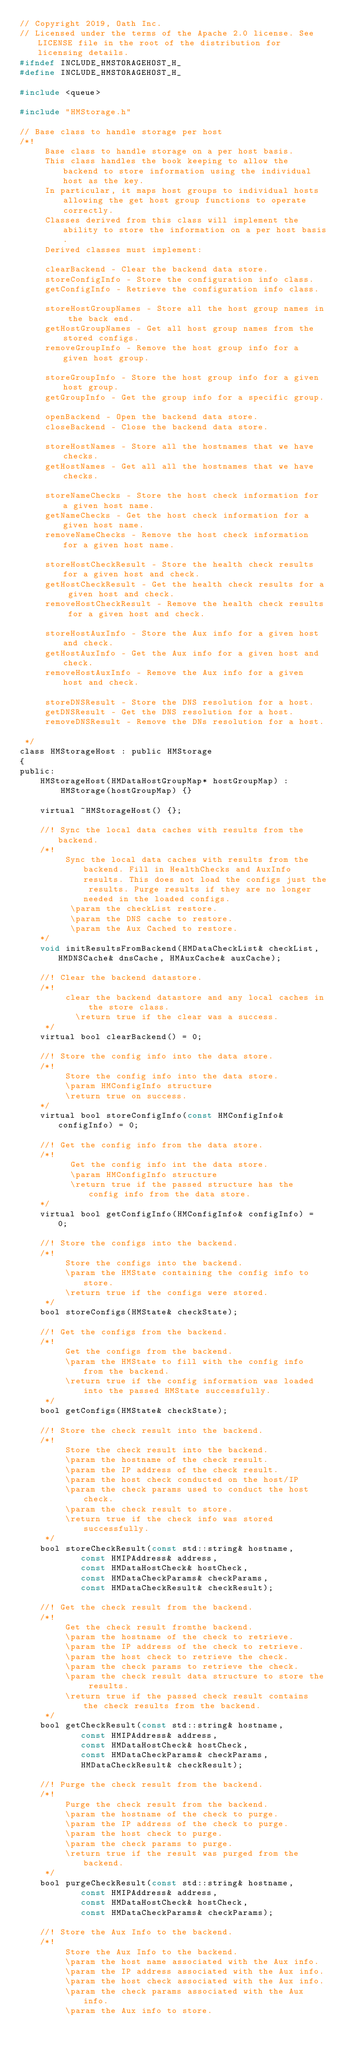<code> <loc_0><loc_0><loc_500><loc_500><_C_>// Copyright 2019, Oath Inc.
// Licensed under the terms of the Apache 2.0 license. See LICENSE file in the root of the distribution for licensing details.
#ifndef INCLUDE_HMSTORAGEHOST_H_
#define INCLUDE_HMSTORAGEHOST_H_

#include <queue>

#include "HMStorage.h"

// Base class to handle storage per host
/*!
     Base class to handle storage on a per host basis.
     This class handles the book keeping to allow the backend to store information using the individual host as the key.
     In particular, it maps host groups to individual hosts allowing the get host group functions to operate correctly.
     Classes derived from this class will implement the ability to store the information on a per host basis.
     Derived classes must implement:

     clearBackend - Clear the backend data store.
     storeConfigInfo - Store the configuration info class.
     getConfigInfo - Retrieve the configuration info class.

     storeHostGroupNames - Store all the host group names in the back end.
     getHostGroupNames - Get all host group names from the stored configs.
     removeGroupInfo - Remove the host group info for a given host group.

     storeGroupInfo - Store the host group info for a given host group.
     getGroupInfo - Get the group info for a specific group.

     openBackend - Open the backend data store.
     closeBackend - Close the backend data store.

     storeHostNames - Store all the hostnames that we have checks.
     getHostNames - Get all all the hostnames that we have checks.

     storeNameChecks - Store the host check information for a given host name.
     getNameChecks - Get the host check information for a given host name.
     removeNameChecks - Remove the host check information for a given host name.

     storeHostCheckResult - Store the health check results for a given host and check.
     getHostCheckResult - Get the health check results for a given host and check.
     removeHostCheckResult - Remove the health check results for a given host and check.

     storeHostAuxInfo - Store the Aux info for a given host and check.
     getHostAuxInfo - Get the Aux info for a given host and check.
     removeHostAuxInfo - Remove the Aux info for a given host and check.

     storeDNSResult - Store the DNS resolution for a host.
     getDNSResult - Get the DNS resolution for a host.
     removeDNSResult - Remove the DNs resolution for a host.

 */
class HMStorageHost : public HMStorage
{
public:
    HMStorageHost(HMDataHostGroupMap* hostGroupMap) :
        HMStorage(hostGroupMap) {}

    virtual ~HMStorageHost() {};

    //! Sync the local data caches with results from the backend.
    /*!
         Sync the local data caches with results from the backend. Fill in HealthChecks and AuxInfo results. This does not load the configs just the results. Purge results if they are no longer needed in the loaded configs.
          \param the checkList restore.
          \param the DNS cache to restore.
          \param the Aux Cached to restore.
    */
    void initResultsFromBackend(HMDataCheckList& checkList, HMDNSCache& dnsCache, HMAuxCache& auxCache);

    //! Clear the backend datastore.
    /*!
         clear the backend datastore and any local caches in the store class.
           \return true if the clear was a success.
     */
    virtual bool clearBackend() = 0;

    //! Store the config info into the data store.
    /*!
         Store the config info into the data store.
         \param HMConfigInfo structure
         \return true on success.
    */
    virtual bool storeConfigInfo(const HMConfigInfo& configInfo) = 0;

    //! Get the config info from the data store.
    /*!
          Get the config info int the data store.
          \param HMConfigInfo structure
          \return true if the passed structure has the config info from the data store.
    */
    virtual bool getConfigInfo(HMConfigInfo& configInfo) = 0;

    //! Store the configs into the backend.
    /*!
         Store the configs into the backend.
         \param the HMState containing the config info to store.
         \return true if the configs were stored.
     */
    bool storeConfigs(HMState& checkState);

    //! Get the configs from the backend.
    /*!
         Get the configs from the backend.
         \param the HMState to fill with the config info from the backend.
         \return true if the config information was loaded into the passed HMState successfully.
     */
    bool getConfigs(HMState& checkState);

    //! Store the check result into the backend.
    /*!
         Store the check result into the backend.
         \param the hostname of the check result.
         \param the IP address of the check result.
         \param the host check conducted on the host/IP
         \param the check params used to conduct the host check.
         \param the check result to store.
         \return true if the check info was stored successfully.
     */
    bool storeCheckResult(const std::string& hostname,
            const HMIPAddress& address,
            const HMDataHostCheck& hostCheck,
            const HMDataCheckParams& checkParams,
            const HMDataCheckResult& checkResult);

    //! Get the check result from the backend.
    /*!
         Get the check result fromthe backend.
         \param the hostname of the check to retrieve.
         \param the IP address of the check to retrieve.
         \param the host check to retrieve the check.
         \param the check params to retrieve the check.
         \param the check result data structure to store the results.
         \return true if the passed check result contains the check results from the backend.
     */
    bool getCheckResult(const std::string& hostname,
            const HMIPAddress& address,
            const HMDataHostCheck& hostCheck,
            const HMDataCheckParams& checkParams,
            HMDataCheckResult& checkResult);

    //! Purge the check result from the backend.
    /*!
         Purge the check result from the backend.
         \param the hostname of the check to purge.
         \param the IP address of the check to purge.
         \param the host check to purge.
         \param the check params to purge.
         \return true if the result was purged from the backend.
     */
    bool purgeCheckResult(const std::string& hostname,
            const HMIPAddress& address,
            const HMDataHostCheck& hostCheck,
            const HMDataCheckParams& checkParams);

    //! Store the Aux Info to the backend.
    /*!
         Store the Aux Info to the backend.
         \param the host name associated with the Aux info.
         \param the IP address associated with the Aux info.
         \param the host check associated with the Aux info.
         \param the check params associated with the Aux info.
         \param the Aux info to store.</code> 